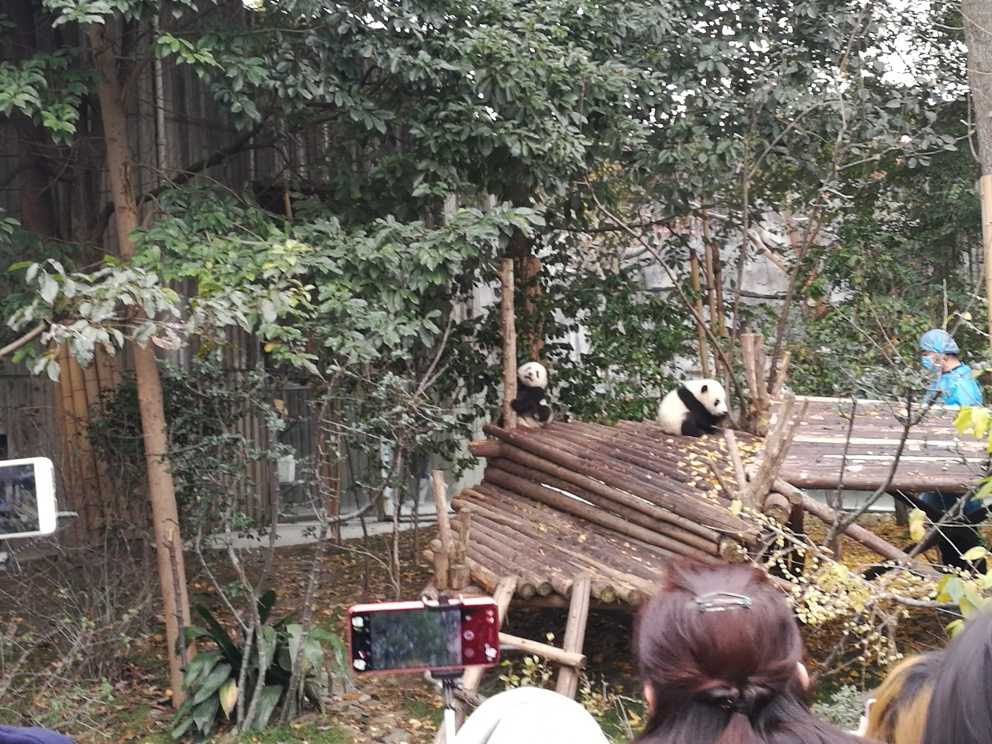Can you tell me more about the creatures visible in the image? The image features two pandas sitting on a wooden platform, surrounded by foliage. Pandas are native to south-central China and are recognized for their distinctive black and white fur. They mainly feed on bamboo and are considered a conservation-reliant vulnerable species. What are the pandas doing right now? It appears that the pandas are resting and casually observing their surroundings. One panda is sitting upright while the other is slightly hunched over, a common relaxed posture for them. 